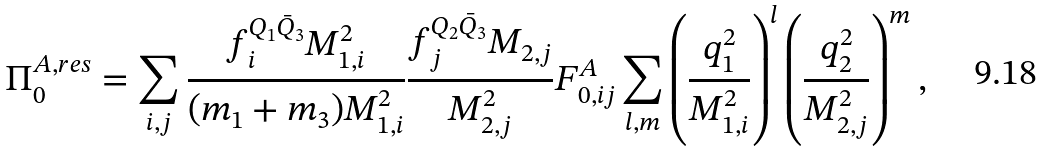Convert formula to latex. <formula><loc_0><loc_0><loc_500><loc_500>\Pi _ { 0 } ^ { A , r e s } = \sum _ { i , j } \frac { f _ { i } ^ { Q _ { 1 } \bar { Q } _ { 3 } } M _ { 1 , i } ^ { 2 } } { ( m _ { 1 } + m _ { 3 } ) M _ { 1 , i } ^ { 2 } } \frac { f _ { j } ^ { Q _ { 2 } \bar { Q } _ { 3 } } M _ { 2 , j } } { M _ { 2 , j } ^ { 2 } } F _ { 0 , i j } ^ { A } \sum _ { l , m } \left ( \frac { q _ { 1 } ^ { 2 } } { M _ { 1 , i } ^ { 2 } } \right ) ^ { l } \left ( \frac { q _ { 2 } ^ { 2 } } { M _ { 2 , j } ^ { 2 } } \right ) ^ { m } ,</formula> 